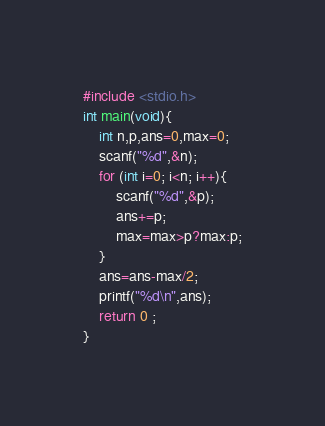Convert code to text. <code><loc_0><loc_0><loc_500><loc_500><_C_>#include <stdio.h>
int main(void){
    int n,p,ans=0,max=0;
    scanf("%d",&n);
    for (int i=0; i<n; i++){
        scanf("%d",&p);
        ans+=p;
        max=max>p?max:p;
    }
    ans=ans-max/2;
    printf("%d\n",ans);
	return 0 ;
}</code> 